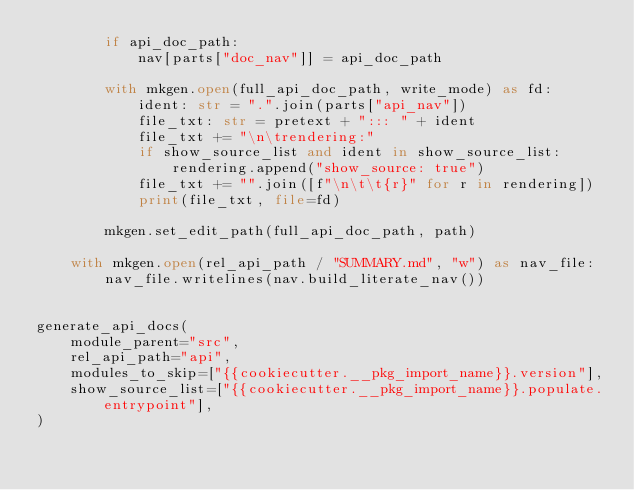<code> <loc_0><loc_0><loc_500><loc_500><_Python_>        if api_doc_path:
            nav[parts["doc_nav"]] = api_doc_path

        with mkgen.open(full_api_doc_path, write_mode) as fd:
            ident: str = ".".join(parts["api_nav"])
            file_txt: str = pretext + "::: " + ident
            file_txt += "\n\trendering:"
            if show_source_list and ident in show_source_list:
                rendering.append("show_source: true")
            file_txt += "".join([f"\n\t\t{r}" for r in rendering])
            print(file_txt, file=fd)

        mkgen.set_edit_path(full_api_doc_path, path)

    with mkgen.open(rel_api_path / "SUMMARY.md", "w") as nav_file:
        nav_file.writelines(nav.build_literate_nav())


generate_api_docs(
    module_parent="src",
    rel_api_path="api",
    modules_to_skip=["{{cookiecutter.__pkg_import_name}}.version"],
    show_source_list=["{{cookiecutter.__pkg_import_name}}.populate.entrypoint"],
)
</code> 